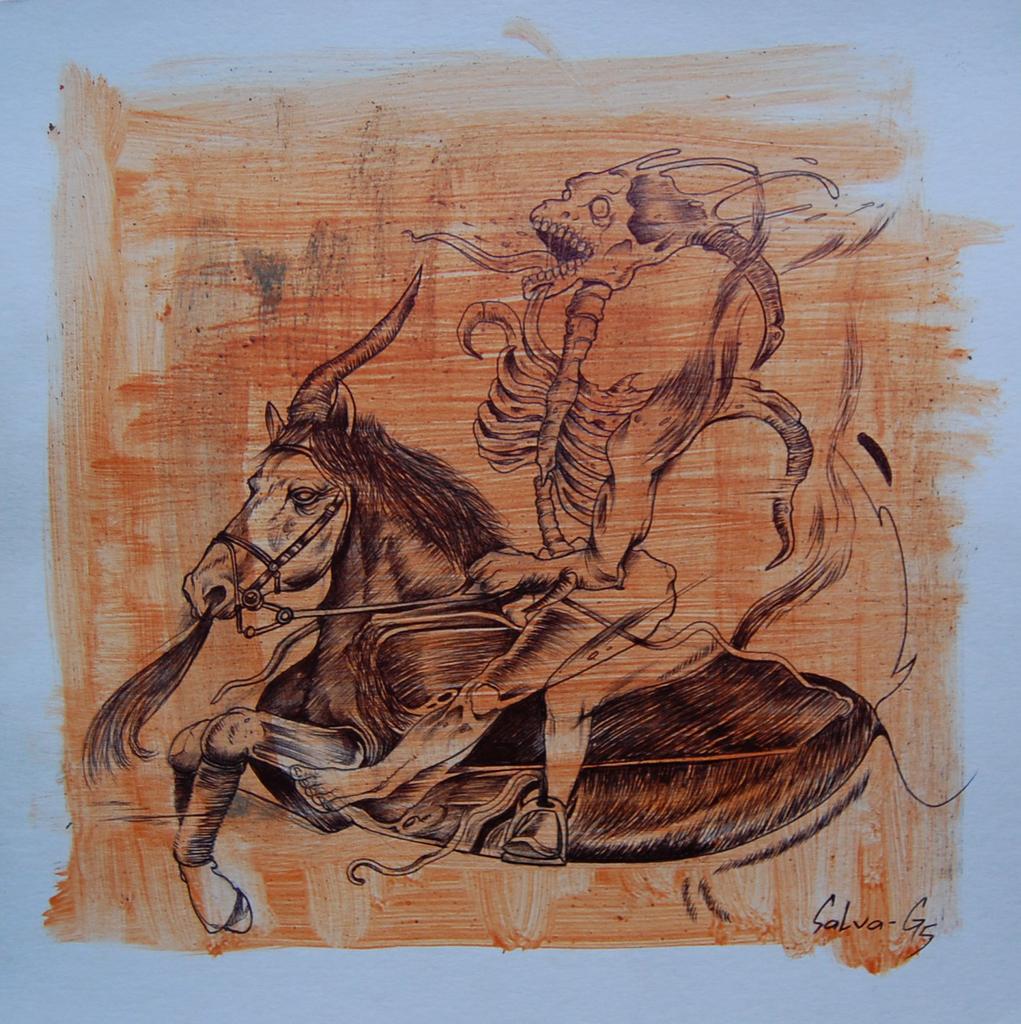Could you give a brief overview of what you see in this image? This is a painting and in this painting we can see a horse running with a skeleton on it. 